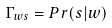Convert formula to latex. <formula><loc_0><loc_0><loc_500><loc_500>\Gamma _ { w s } = P r ( s | w )</formula> 